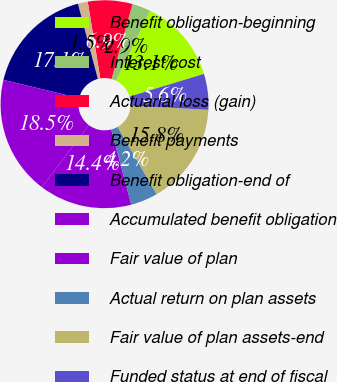<chart> <loc_0><loc_0><loc_500><loc_500><pie_chart><fcel>Benefit obligation-beginning<fcel>Interest cost<fcel>Actuarial loss (gain)<fcel>Benefit payments<fcel>Benefit obligation-end of<fcel>Accumulated benefit obligation<fcel>Fair value of plan<fcel>Actual return on plan assets<fcel>Fair value of plan assets-end<fcel>Funded status at end of fiscal<nl><fcel>13.08%<fcel>2.88%<fcel>6.92%<fcel>1.53%<fcel>17.12%<fcel>18.47%<fcel>14.43%<fcel>4.22%<fcel>15.78%<fcel>5.57%<nl></chart> 